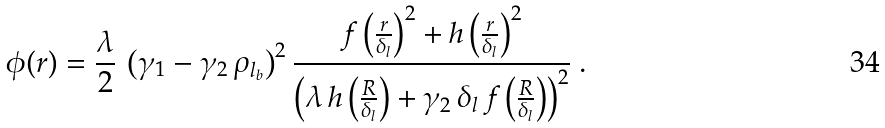<formula> <loc_0><loc_0><loc_500><loc_500>\phi ( r ) = \frac { \lambda } { 2 } \, \left ( \gamma _ { 1 } - \gamma _ { 2 } \, \rho _ { l _ { b } } \right ) ^ { 2 } \frac { f \left ( \frac { r } { \delta _ { l } } \right ) ^ { 2 } + h \left ( \frac { r } { \delta _ { l } } \right ) ^ { 2 } } { \left ( \lambda \, h \left ( \frac { R } { \delta _ { l } } \right ) + \gamma _ { 2 } \, \delta _ { l } \, f \left ( \frac { R } { \delta _ { l } } \right ) \right ) ^ { 2 } } \ .</formula> 